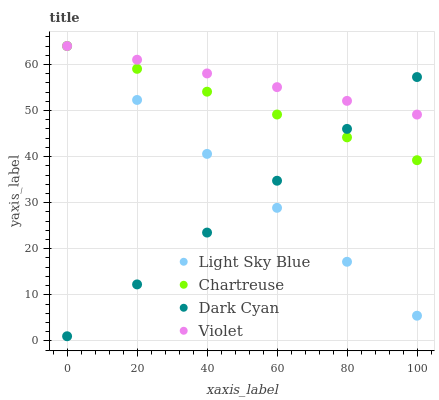Does Dark Cyan have the minimum area under the curve?
Answer yes or no. Yes. Does Violet have the maximum area under the curve?
Answer yes or no. Yes. Does Chartreuse have the minimum area under the curve?
Answer yes or no. No. Does Chartreuse have the maximum area under the curve?
Answer yes or no. No. Is Light Sky Blue the smoothest?
Answer yes or no. Yes. Is Dark Cyan the roughest?
Answer yes or no. Yes. Is Chartreuse the smoothest?
Answer yes or no. No. Is Chartreuse the roughest?
Answer yes or no. No. Does Dark Cyan have the lowest value?
Answer yes or no. Yes. Does Chartreuse have the lowest value?
Answer yes or no. No. Does Violet have the highest value?
Answer yes or no. Yes. Does Chartreuse intersect Violet?
Answer yes or no. Yes. Is Chartreuse less than Violet?
Answer yes or no. No. Is Chartreuse greater than Violet?
Answer yes or no. No. 